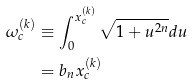Convert formula to latex. <formula><loc_0><loc_0><loc_500><loc_500>\omega _ { c } ^ { ( k ) } & \equiv \int _ { 0 } ^ { x _ { c } ^ { ( k ) } } \sqrt { 1 + u ^ { 2 n } } d u \\ & = b _ { n } x _ { c } ^ { ( k ) }</formula> 